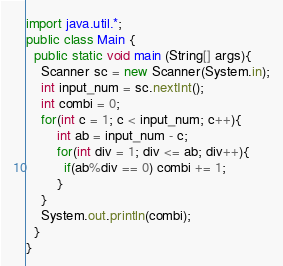Convert code to text. <code><loc_0><loc_0><loc_500><loc_500><_Java_>import java.util.*;
public class Main {
  public static void main (String[] args){
	Scanner sc = new Scanner(System.in);
    int input_num = sc.nextInt();
    int combi = 0;
    for(int c = 1; c < input_num; c++){
    	int ab = input_num - c;
      	for(int div = 1; div <= ab; div++){
          if(ab%div == 0) combi += 1;
        }
    }
    System.out.println(combi);
  }
}
</code> 